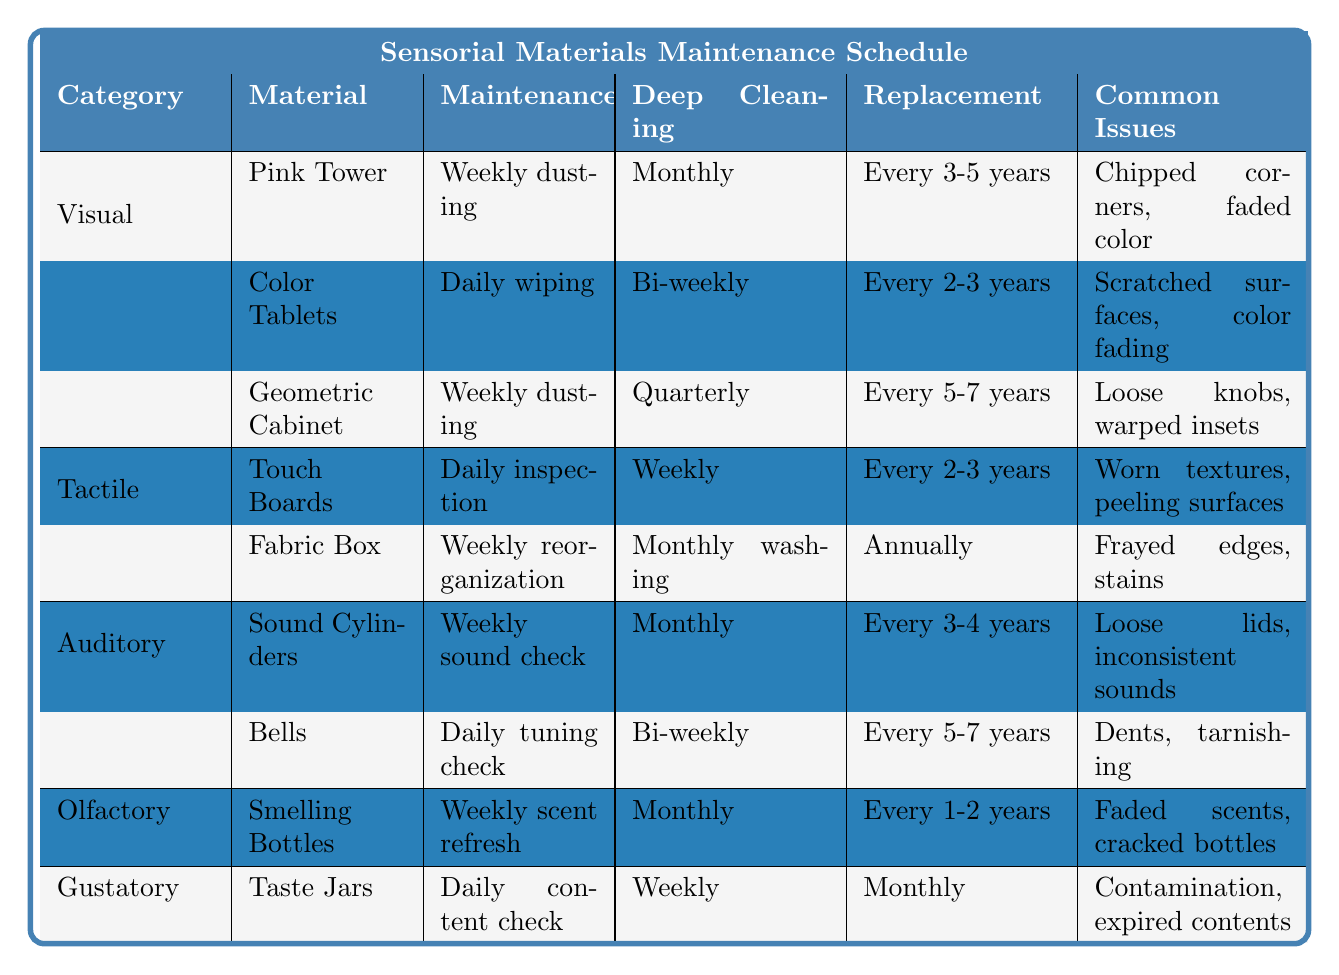What is the replacement frequency for the Color Tablets? According to the table, the replacement frequency for Color Tablets is listed as "Every 2-3 years." This value can be found in the row corresponding to the Color Tablets under the column for Replacement Frequency.
Answer: Every 2-3 years How often do the Fabric Box materials require deep cleaning? The table indicates that the Fabric Box materials require deep cleaning on a "Monthly" basis. This is found directly in the row corresponding to Fabric Box under the Deep Cleaning column.
Answer: Monthly Which materials require weekly maintenance in the Visual category? In the Visual category, the materials that require weekly maintenance are the Pink Tower and the Geometric Cabinet. This can be determined by checking the Maintenance column for materials listed under the Visual category.
Answer: Pink Tower and Geometric Cabinet Are the Smelling Bottles replaced more frequently than the Sound Cylinders? Yes, Smelling Bottles are replaced every 1-2 years, while Sound Cylinders are replaced every 3-4 years, indicating that Smelling Bottles have a shorter replacement frequency. We compare the values listed in the table for both items to reach this conclusion.
Answer: Yes How many different maintenance types are listed for the Tactile category materials? The Tactile category materials have two different maintenance types listed: "Daily inspection" for Touch Boards and "Weekly reorganization" for Fabric Box. Each unique maintenance activity is counted to provide this total.
Answer: 2 Which sensory material has the most frequent replacement frequency, and what is that frequency? The Taste Jars have the most frequent replacement frequency of "Monthly," as indicated by the frequency listed. This requires checking the Replacement Frequency for all materials in the Gustatory category.
Answer: Taste Jars, Monthly How does the deep cleaning schedule of the Touch Boards compare to that of the Sound Cylinders? The Touch Boards require deep cleaning weekly, while the Sound Cylinders require deep cleaning monthly. This comparison is made by evaluating the Deep Cleaning column for both materials.
Answer: Touch Boards weekly, Sound Cylinders monthly Which category has materials with the longest replacement frequency, and what is that frequency? The Visual category contains materials with the longest replacement frequency, specifically the Geometric Cabinet at "Every 5-7 years." This is determined by checking the Replacement Frequency values for all items, noting the highest frequency value.
Answer: Visual category, Every 5-7 years Is there any material in the table that requires daily maintenance? If so, which ones? Yes, both the Color Tablets and the Taste Jars require daily maintenance. This can be confirmed by finding the daily maintenance listed in the Maintenance column for each respective material.
Answer: Yes, Color Tablets and Taste Jars If you wanted to minimize the number of replacements per year, which category would you choose? The Olfactory category requires the least frequent replacements, with Smelling Bottles needing replacement every 1-2 years. Therefore, choosing this category would minimize replacements annually. This is determined by comparing all the Replacement Frequencies in the table.
Answer: Olfactory category 